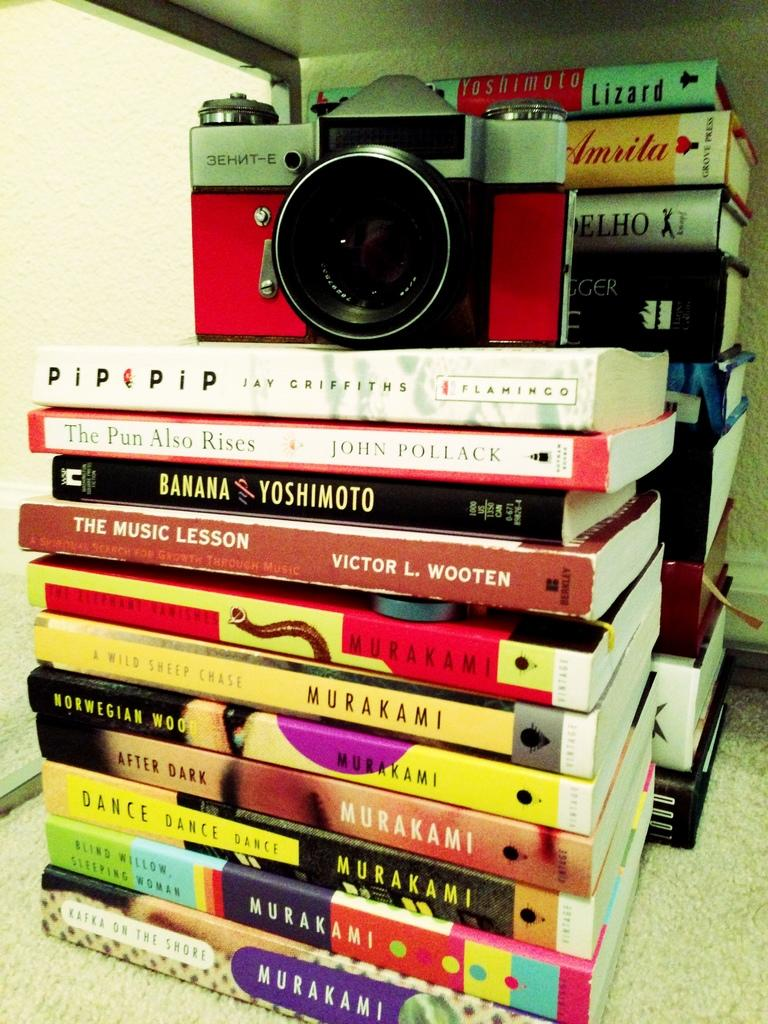What objects are located in the center of the image? There are books and a camera in the center of the image. Can you describe the books in the image? Unfortunately, the image does not provide enough detail to describe the books. What is the purpose of the camera in the image? The purpose of the camera in the image is not clear, as there is no context provided. What grade does the noise level receive in the image? There is no mention of noise or grades in the image, so this question cannot be answered. 